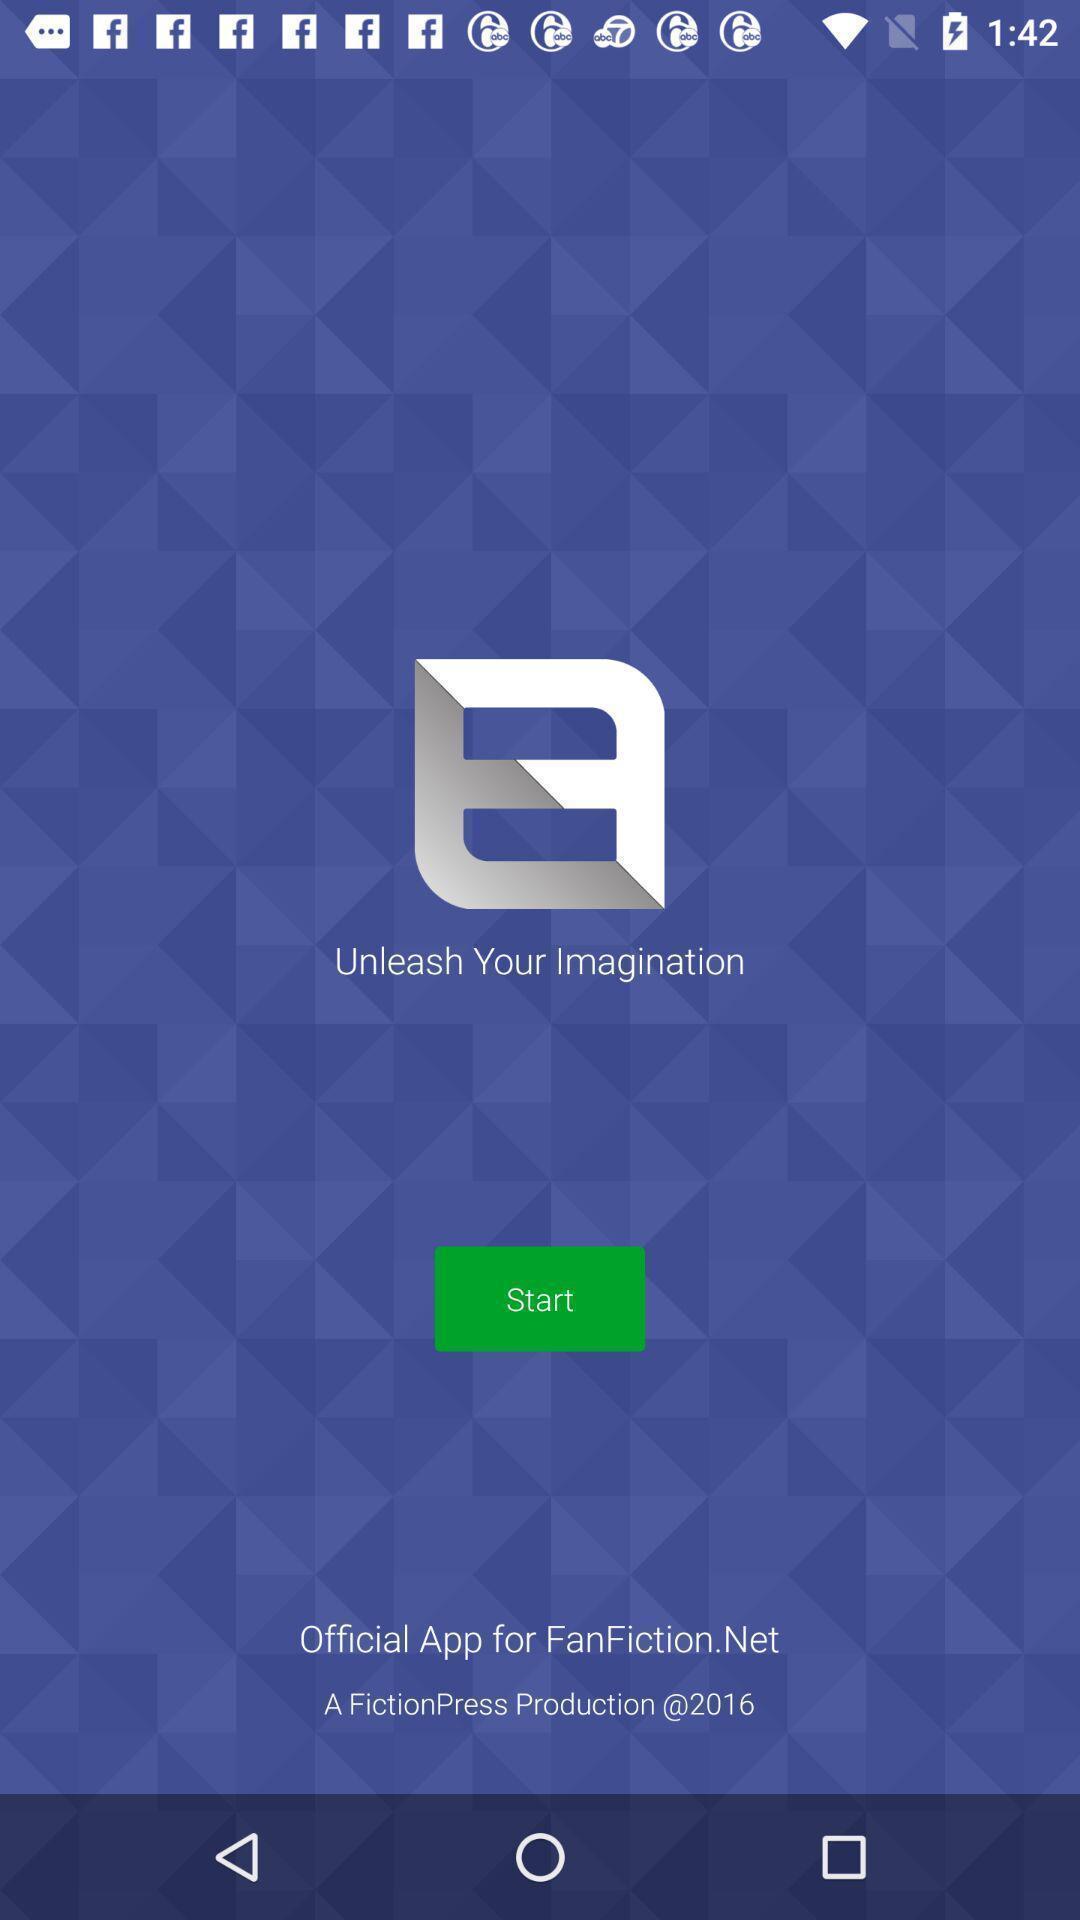Describe this image in words. Welcome page. 